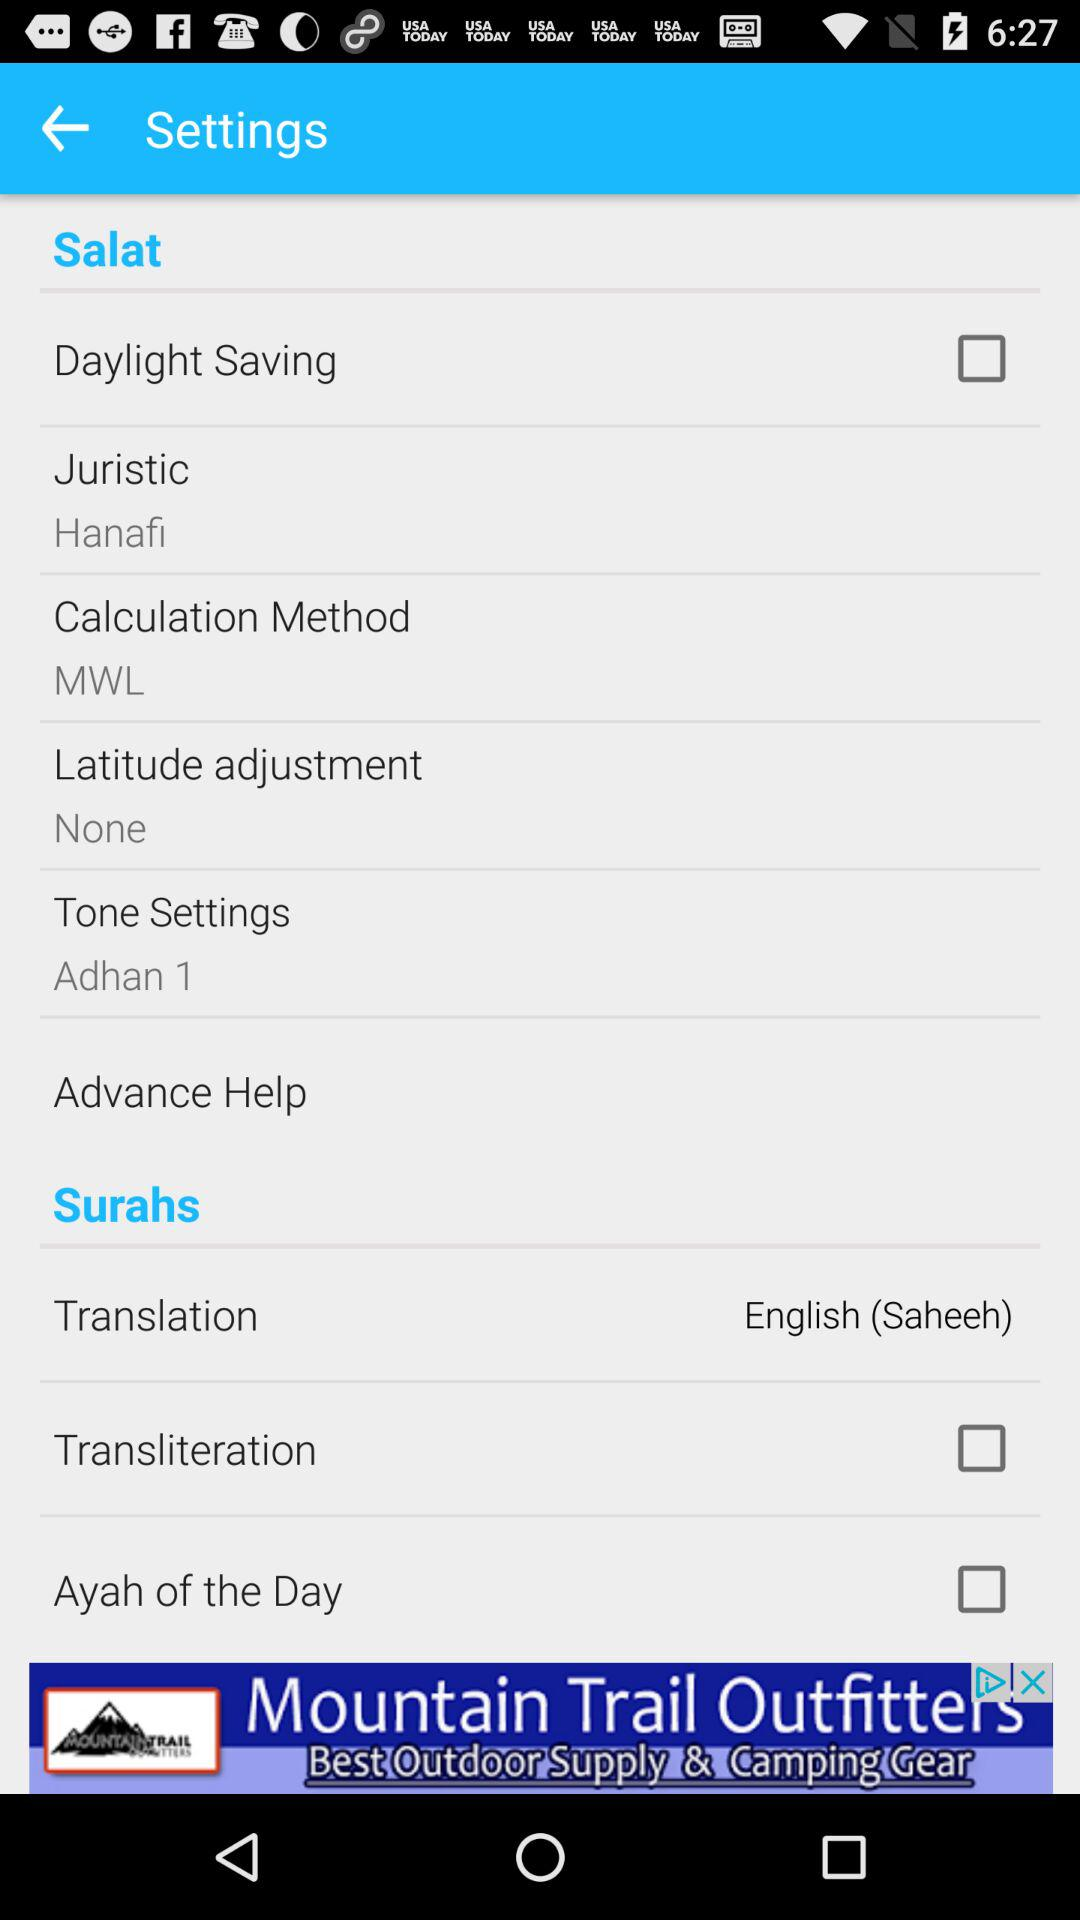What is the applied juristic method? The applied juristic method is "Hanafi". 